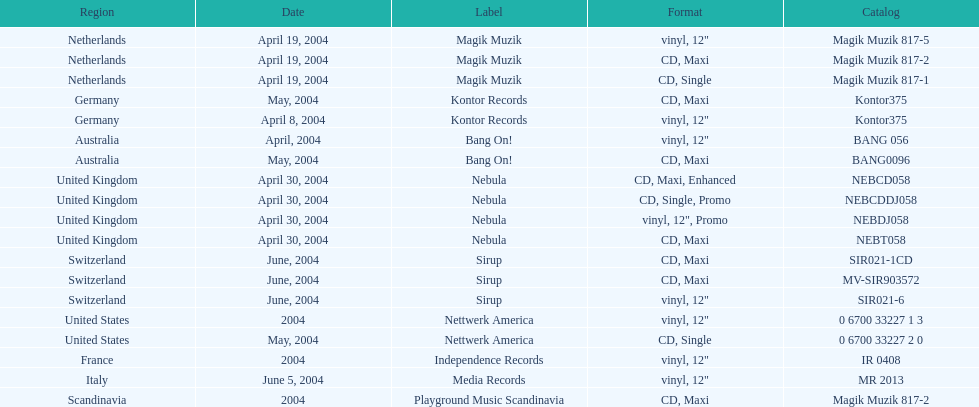How many directories were published? 19. 